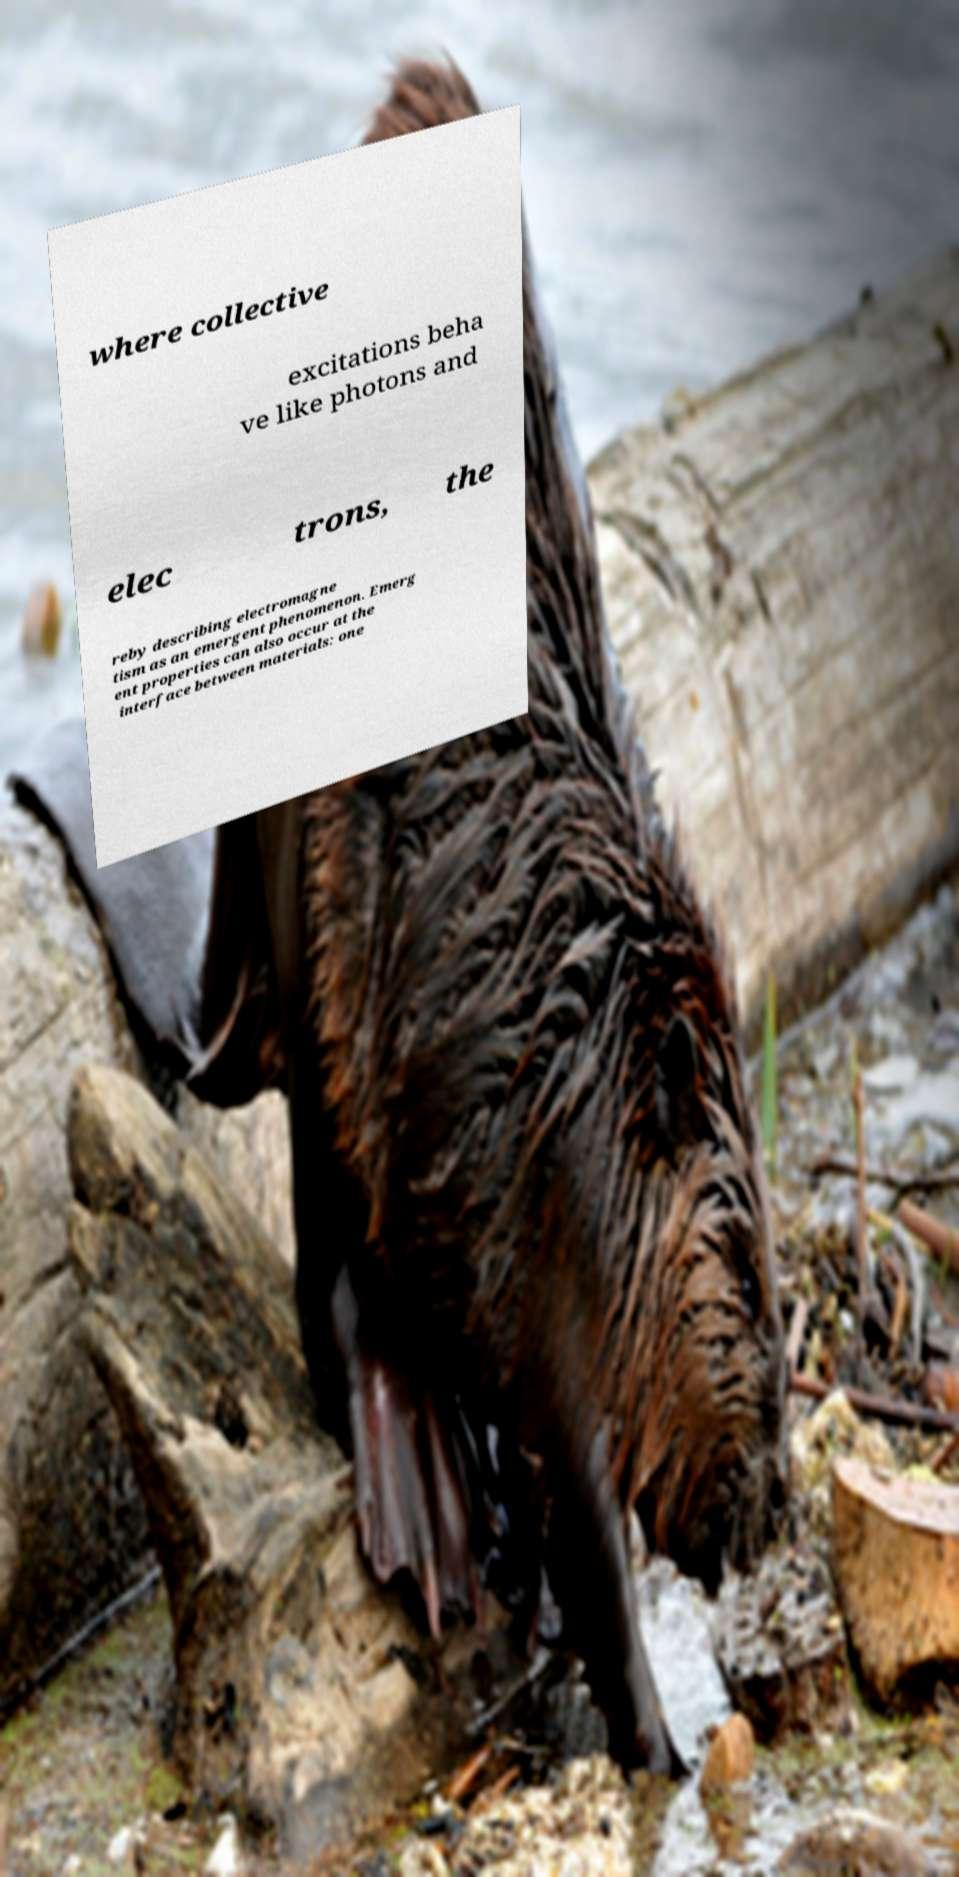Please read and relay the text visible in this image. What does it say? where collective excitations beha ve like photons and elec trons, the reby describing electromagne tism as an emergent phenomenon. Emerg ent properties can also occur at the interface between materials: one 